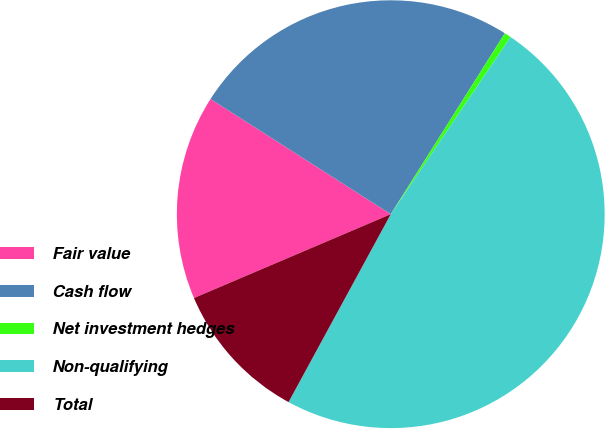Convert chart. <chart><loc_0><loc_0><loc_500><loc_500><pie_chart><fcel>Fair value<fcel>Cash flow<fcel>Net investment hedges<fcel>Non-qualifying<fcel>Total<nl><fcel>15.46%<fcel>24.9%<fcel>0.51%<fcel>48.46%<fcel>10.66%<nl></chart> 